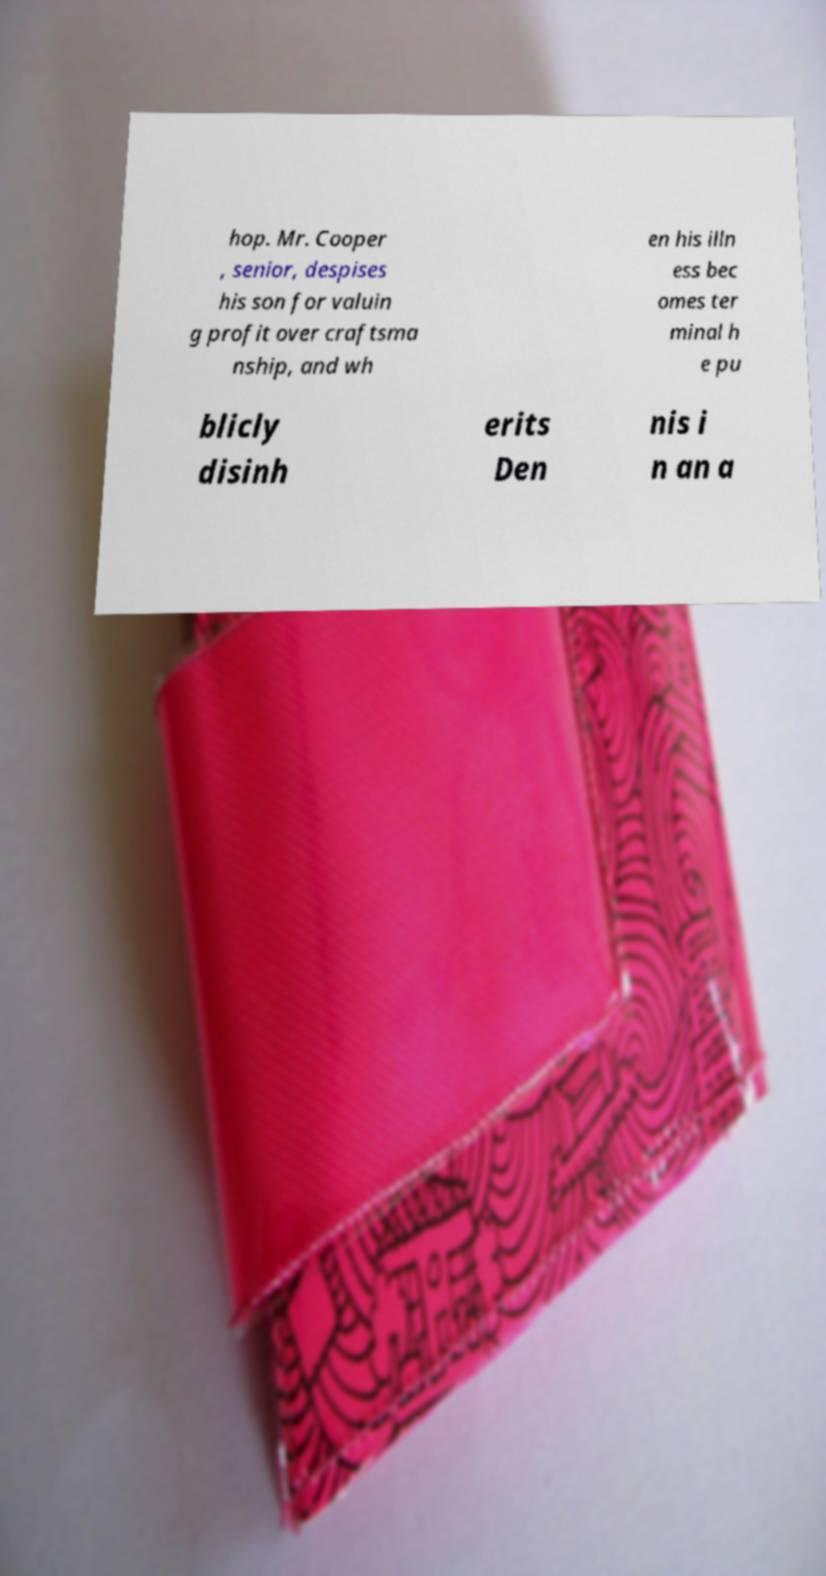Could you extract and type out the text from this image? hop. Mr. Cooper , senior, despises his son for valuin g profit over craftsma nship, and wh en his illn ess bec omes ter minal h e pu blicly disinh erits Den nis i n an a 